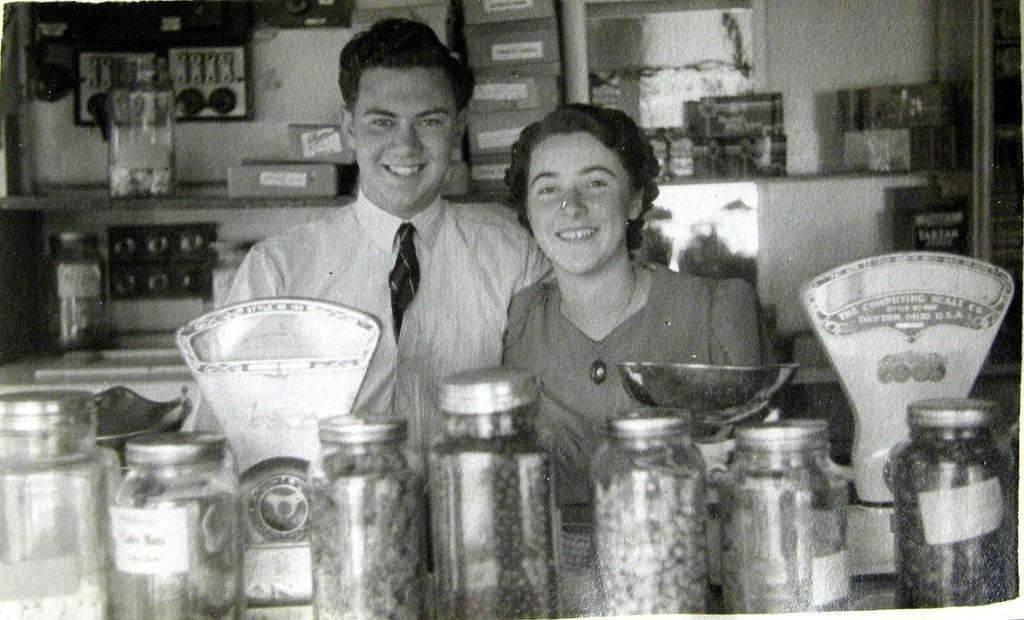Please provide a concise description of this image. In the image it is a black and white picture, there are two people standing inside a store and in front of them there are many bottles filled with some grocery items and there are also two weighing machines, behind these two people there are few electronic tools and also some other materials. 